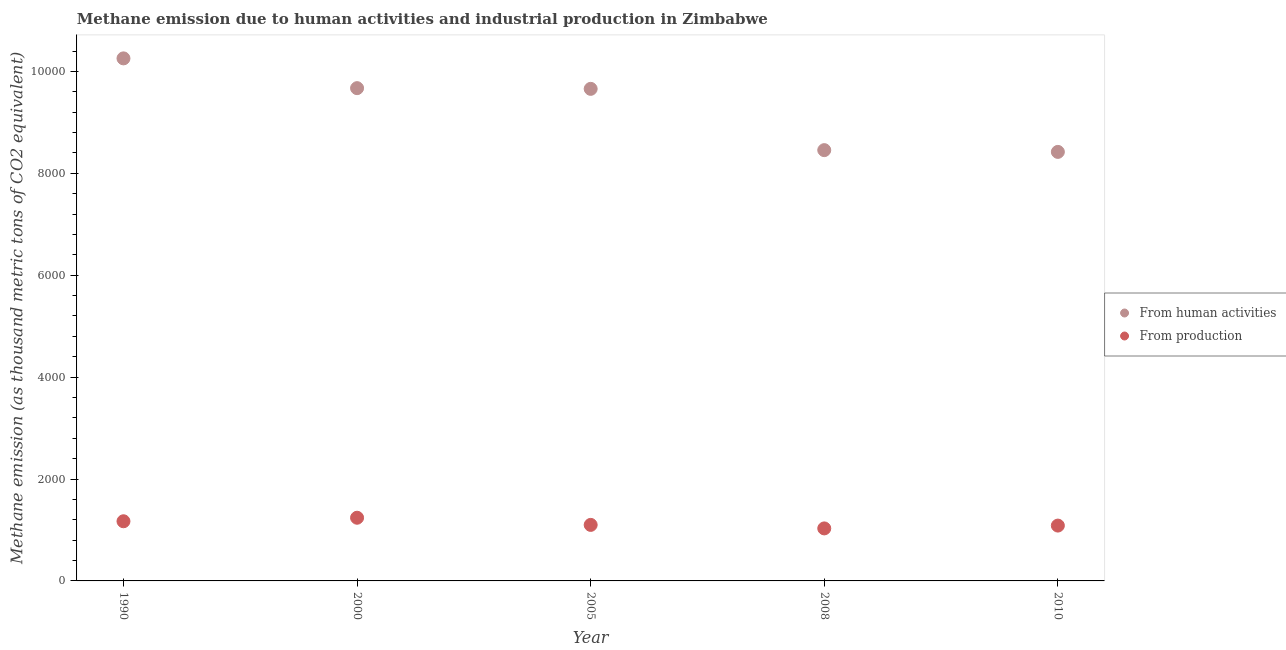Is the number of dotlines equal to the number of legend labels?
Offer a very short reply. Yes. What is the amount of emissions from human activities in 2010?
Ensure brevity in your answer.  8420.5. Across all years, what is the maximum amount of emissions generated from industries?
Offer a terse response. 1240.1. Across all years, what is the minimum amount of emissions generated from industries?
Your answer should be compact. 1030.7. In which year was the amount of emissions from human activities maximum?
Your answer should be very brief. 1990. In which year was the amount of emissions from human activities minimum?
Keep it short and to the point. 2010. What is the total amount of emissions generated from industries in the graph?
Keep it short and to the point. 5627.5. What is the difference between the amount of emissions generated from industries in 2005 and that in 2008?
Offer a very short reply. 69. What is the difference between the amount of emissions generated from industries in 2010 and the amount of emissions from human activities in 2000?
Ensure brevity in your answer.  -8585.5. What is the average amount of emissions generated from industries per year?
Offer a terse response. 1125.5. In the year 1990, what is the difference between the amount of emissions from human activities and amount of emissions generated from industries?
Your answer should be compact. 9085.1. In how many years, is the amount of emissions generated from industries greater than 3200 thousand metric tons?
Your answer should be very brief. 0. What is the ratio of the amount of emissions generated from industries in 2008 to that in 2010?
Your answer should be very brief. 0.95. Is the amount of emissions generated from industries in 2005 less than that in 2010?
Provide a short and direct response. No. Is the difference between the amount of emissions generated from industries in 2008 and 2010 greater than the difference between the amount of emissions from human activities in 2008 and 2010?
Your response must be concise. No. What is the difference between the highest and the second highest amount of emissions from human activities?
Your answer should be compact. 584.4. What is the difference between the highest and the lowest amount of emissions from human activities?
Ensure brevity in your answer.  1835.5. In how many years, is the amount of emissions from human activities greater than the average amount of emissions from human activities taken over all years?
Give a very brief answer. 3. Is the sum of the amount of emissions generated from industries in 1990 and 2005 greater than the maximum amount of emissions from human activities across all years?
Your answer should be compact. No. Does the amount of emissions from human activities monotonically increase over the years?
Offer a very short reply. No. Is the amount of emissions generated from industries strictly greater than the amount of emissions from human activities over the years?
Ensure brevity in your answer.  No. How many dotlines are there?
Provide a short and direct response. 2. How many years are there in the graph?
Provide a short and direct response. 5. What is the difference between two consecutive major ticks on the Y-axis?
Ensure brevity in your answer.  2000. How are the legend labels stacked?
Give a very brief answer. Vertical. What is the title of the graph?
Make the answer very short. Methane emission due to human activities and industrial production in Zimbabwe. Does "Manufacturing industries and construction" appear as one of the legend labels in the graph?
Keep it short and to the point. No. What is the label or title of the X-axis?
Offer a very short reply. Year. What is the label or title of the Y-axis?
Provide a short and direct response. Methane emission (as thousand metric tons of CO2 equivalent). What is the Methane emission (as thousand metric tons of CO2 equivalent) of From human activities in 1990?
Provide a short and direct response. 1.03e+04. What is the Methane emission (as thousand metric tons of CO2 equivalent) in From production in 1990?
Make the answer very short. 1170.9. What is the Methane emission (as thousand metric tons of CO2 equivalent) of From human activities in 2000?
Your answer should be very brief. 9671.6. What is the Methane emission (as thousand metric tons of CO2 equivalent) in From production in 2000?
Provide a succinct answer. 1240.1. What is the Methane emission (as thousand metric tons of CO2 equivalent) in From human activities in 2005?
Provide a short and direct response. 9657.9. What is the Methane emission (as thousand metric tons of CO2 equivalent) in From production in 2005?
Ensure brevity in your answer.  1099.7. What is the Methane emission (as thousand metric tons of CO2 equivalent) of From human activities in 2008?
Make the answer very short. 8455. What is the Methane emission (as thousand metric tons of CO2 equivalent) of From production in 2008?
Make the answer very short. 1030.7. What is the Methane emission (as thousand metric tons of CO2 equivalent) of From human activities in 2010?
Your answer should be very brief. 8420.5. What is the Methane emission (as thousand metric tons of CO2 equivalent) of From production in 2010?
Give a very brief answer. 1086.1. Across all years, what is the maximum Methane emission (as thousand metric tons of CO2 equivalent) of From human activities?
Keep it short and to the point. 1.03e+04. Across all years, what is the maximum Methane emission (as thousand metric tons of CO2 equivalent) of From production?
Make the answer very short. 1240.1. Across all years, what is the minimum Methane emission (as thousand metric tons of CO2 equivalent) in From human activities?
Your answer should be very brief. 8420.5. Across all years, what is the minimum Methane emission (as thousand metric tons of CO2 equivalent) of From production?
Your answer should be compact. 1030.7. What is the total Methane emission (as thousand metric tons of CO2 equivalent) in From human activities in the graph?
Make the answer very short. 4.65e+04. What is the total Methane emission (as thousand metric tons of CO2 equivalent) of From production in the graph?
Make the answer very short. 5627.5. What is the difference between the Methane emission (as thousand metric tons of CO2 equivalent) of From human activities in 1990 and that in 2000?
Offer a very short reply. 584.4. What is the difference between the Methane emission (as thousand metric tons of CO2 equivalent) of From production in 1990 and that in 2000?
Provide a succinct answer. -69.2. What is the difference between the Methane emission (as thousand metric tons of CO2 equivalent) in From human activities in 1990 and that in 2005?
Keep it short and to the point. 598.1. What is the difference between the Methane emission (as thousand metric tons of CO2 equivalent) in From production in 1990 and that in 2005?
Offer a terse response. 71.2. What is the difference between the Methane emission (as thousand metric tons of CO2 equivalent) of From human activities in 1990 and that in 2008?
Provide a succinct answer. 1801. What is the difference between the Methane emission (as thousand metric tons of CO2 equivalent) of From production in 1990 and that in 2008?
Provide a short and direct response. 140.2. What is the difference between the Methane emission (as thousand metric tons of CO2 equivalent) in From human activities in 1990 and that in 2010?
Your answer should be compact. 1835.5. What is the difference between the Methane emission (as thousand metric tons of CO2 equivalent) of From production in 1990 and that in 2010?
Keep it short and to the point. 84.8. What is the difference between the Methane emission (as thousand metric tons of CO2 equivalent) of From human activities in 2000 and that in 2005?
Offer a terse response. 13.7. What is the difference between the Methane emission (as thousand metric tons of CO2 equivalent) in From production in 2000 and that in 2005?
Offer a very short reply. 140.4. What is the difference between the Methane emission (as thousand metric tons of CO2 equivalent) of From human activities in 2000 and that in 2008?
Ensure brevity in your answer.  1216.6. What is the difference between the Methane emission (as thousand metric tons of CO2 equivalent) in From production in 2000 and that in 2008?
Offer a very short reply. 209.4. What is the difference between the Methane emission (as thousand metric tons of CO2 equivalent) of From human activities in 2000 and that in 2010?
Your answer should be compact. 1251.1. What is the difference between the Methane emission (as thousand metric tons of CO2 equivalent) of From production in 2000 and that in 2010?
Offer a very short reply. 154. What is the difference between the Methane emission (as thousand metric tons of CO2 equivalent) in From human activities in 2005 and that in 2008?
Your response must be concise. 1202.9. What is the difference between the Methane emission (as thousand metric tons of CO2 equivalent) in From production in 2005 and that in 2008?
Your answer should be very brief. 69. What is the difference between the Methane emission (as thousand metric tons of CO2 equivalent) in From human activities in 2005 and that in 2010?
Ensure brevity in your answer.  1237.4. What is the difference between the Methane emission (as thousand metric tons of CO2 equivalent) in From human activities in 2008 and that in 2010?
Keep it short and to the point. 34.5. What is the difference between the Methane emission (as thousand metric tons of CO2 equivalent) in From production in 2008 and that in 2010?
Give a very brief answer. -55.4. What is the difference between the Methane emission (as thousand metric tons of CO2 equivalent) of From human activities in 1990 and the Methane emission (as thousand metric tons of CO2 equivalent) of From production in 2000?
Offer a very short reply. 9015.9. What is the difference between the Methane emission (as thousand metric tons of CO2 equivalent) of From human activities in 1990 and the Methane emission (as thousand metric tons of CO2 equivalent) of From production in 2005?
Provide a short and direct response. 9156.3. What is the difference between the Methane emission (as thousand metric tons of CO2 equivalent) in From human activities in 1990 and the Methane emission (as thousand metric tons of CO2 equivalent) in From production in 2008?
Give a very brief answer. 9225.3. What is the difference between the Methane emission (as thousand metric tons of CO2 equivalent) of From human activities in 1990 and the Methane emission (as thousand metric tons of CO2 equivalent) of From production in 2010?
Provide a succinct answer. 9169.9. What is the difference between the Methane emission (as thousand metric tons of CO2 equivalent) in From human activities in 2000 and the Methane emission (as thousand metric tons of CO2 equivalent) in From production in 2005?
Offer a terse response. 8571.9. What is the difference between the Methane emission (as thousand metric tons of CO2 equivalent) in From human activities in 2000 and the Methane emission (as thousand metric tons of CO2 equivalent) in From production in 2008?
Ensure brevity in your answer.  8640.9. What is the difference between the Methane emission (as thousand metric tons of CO2 equivalent) of From human activities in 2000 and the Methane emission (as thousand metric tons of CO2 equivalent) of From production in 2010?
Your answer should be very brief. 8585.5. What is the difference between the Methane emission (as thousand metric tons of CO2 equivalent) in From human activities in 2005 and the Methane emission (as thousand metric tons of CO2 equivalent) in From production in 2008?
Offer a very short reply. 8627.2. What is the difference between the Methane emission (as thousand metric tons of CO2 equivalent) of From human activities in 2005 and the Methane emission (as thousand metric tons of CO2 equivalent) of From production in 2010?
Your answer should be very brief. 8571.8. What is the difference between the Methane emission (as thousand metric tons of CO2 equivalent) of From human activities in 2008 and the Methane emission (as thousand metric tons of CO2 equivalent) of From production in 2010?
Provide a short and direct response. 7368.9. What is the average Methane emission (as thousand metric tons of CO2 equivalent) in From human activities per year?
Your response must be concise. 9292.2. What is the average Methane emission (as thousand metric tons of CO2 equivalent) of From production per year?
Your response must be concise. 1125.5. In the year 1990, what is the difference between the Methane emission (as thousand metric tons of CO2 equivalent) of From human activities and Methane emission (as thousand metric tons of CO2 equivalent) of From production?
Offer a very short reply. 9085.1. In the year 2000, what is the difference between the Methane emission (as thousand metric tons of CO2 equivalent) in From human activities and Methane emission (as thousand metric tons of CO2 equivalent) in From production?
Your answer should be compact. 8431.5. In the year 2005, what is the difference between the Methane emission (as thousand metric tons of CO2 equivalent) of From human activities and Methane emission (as thousand metric tons of CO2 equivalent) of From production?
Give a very brief answer. 8558.2. In the year 2008, what is the difference between the Methane emission (as thousand metric tons of CO2 equivalent) in From human activities and Methane emission (as thousand metric tons of CO2 equivalent) in From production?
Ensure brevity in your answer.  7424.3. In the year 2010, what is the difference between the Methane emission (as thousand metric tons of CO2 equivalent) in From human activities and Methane emission (as thousand metric tons of CO2 equivalent) in From production?
Offer a very short reply. 7334.4. What is the ratio of the Methane emission (as thousand metric tons of CO2 equivalent) of From human activities in 1990 to that in 2000?
Keep it short and to the point. 1.06. What is the ratio of the Methane emission (as thousand metric tons of CO2 equivalent) in From production in 1990 to that in 2000?
Provide a succinct answer. 0.94. What is the ratio of the Methane emission (as thousand metric tons of CO2 equivalent) in From human activities in 1990 to that in 2005?
Your answer should be compact. 1.06. What is the ratio of the Methane emission (as thousand metric tons of CO2 equivalent) of From production in 1990 to that in 2005?
Ensure brevity in your answer.  1.06. What is the ratio of the Methane emission (as thousand metric tons of CO2 equivalent) of From human activities in 1990 to that in 2008?
Your answer should be compact. 1.21. What is the ratio of the Methane emission (as thousand metric tons of CO2 equivalent) of From production in 1990 to that in 2008?
Offer a terse response. 1.14. What is the ratio of the Methane emission (as thousand metric tons of CO2 equivalent) in From human activities in 1990 to that in 2010?
Make the answer very short. 1.22. What is the ratio of the Methane emission (as thousand metric tons of CO2 equivalent) in From production in 1990 to that in 2010?
Ensure brevity in your answer.  1.08. What is the ratio of the Methane emission (as thousand metric tons of CO2 equivalent) of From production in 2000 to that in 2005?
Your answer should be very brief. 1.13. What is the ratio of the Methane emission (as thousand metric tons of CO2 equivalent) of From human activities in 2000 to that in 2008?
Your answer should be compact. 1.14. What is the ratio of the Methane emission (as thousand metric tons of CO2 equivalent) in From production in 2000 to that in 2008?
Offer a very short reply. 1.2. What is the ratio of the Methane emission (as thousand metric tons of CO2 equivalent) in From human activities in 2000 to that in 2010?
Your answer should be compact. 1.15. What is the ratio of the Methane emission (as thousand metric tons of CO2 equivalent) in From production in 2000 to that in 2010?
Keep it short and to the point. 1.14. What is the ratio of the Methane emission (as thousand metric tons of CO2 equivalent) of From human activities in 2005 to that in 2008?
Provide a short and direct response. 1.14. What is the ratio of the Methane emission (as thousand metric tons of CO2 equivalent) in From production in 2005 to that in 2008?
Your answer should be very brief. 1.07. What is the ratio of the Methane emission (as thousand metric tons of CO2 equivalent) in From human activities in 2005 to that in 2010?
Keep it short and to the point. 1.15. What is the ratio of the Methane emission (as thousand metric tons of CO2 equivalent) in From production in 2005 to that in 2010?
Your response must be concise. 1.01. What is the ratio of the Methane emission (as thousand metric tons of CO2 equivalent) in From human activities in 2008 to that in 2010?
Offer a very short reply. 1. What is the ratio of the Methane emission (as thousand metric tons of CO2 equivalent) of From production in 2008 to that in 2010?
Your answer should be compact. 0.95. What is the difference between the highest and the second highest Methane emission (as thousand metric tons of CO2 equivalent) of From human activities?
Keep it short and to the point. 584.4. What is the difference between the highest and the second highest Methane emission (as thousand metric tons of CO2 equivalent) in From production?
Offer a very short reply. 69.2. What is the difference between the highest and the lowest Methane emission (as thousand metric tons of CO2 equivalent) in From human activities?
Give a very brief answer. 1835.5. What is the difference between the highest and the lowest Methane emission (as thousand metric tons of CO2 equivalent) in From production?
Ensure brevity in your answer.  209.4. 